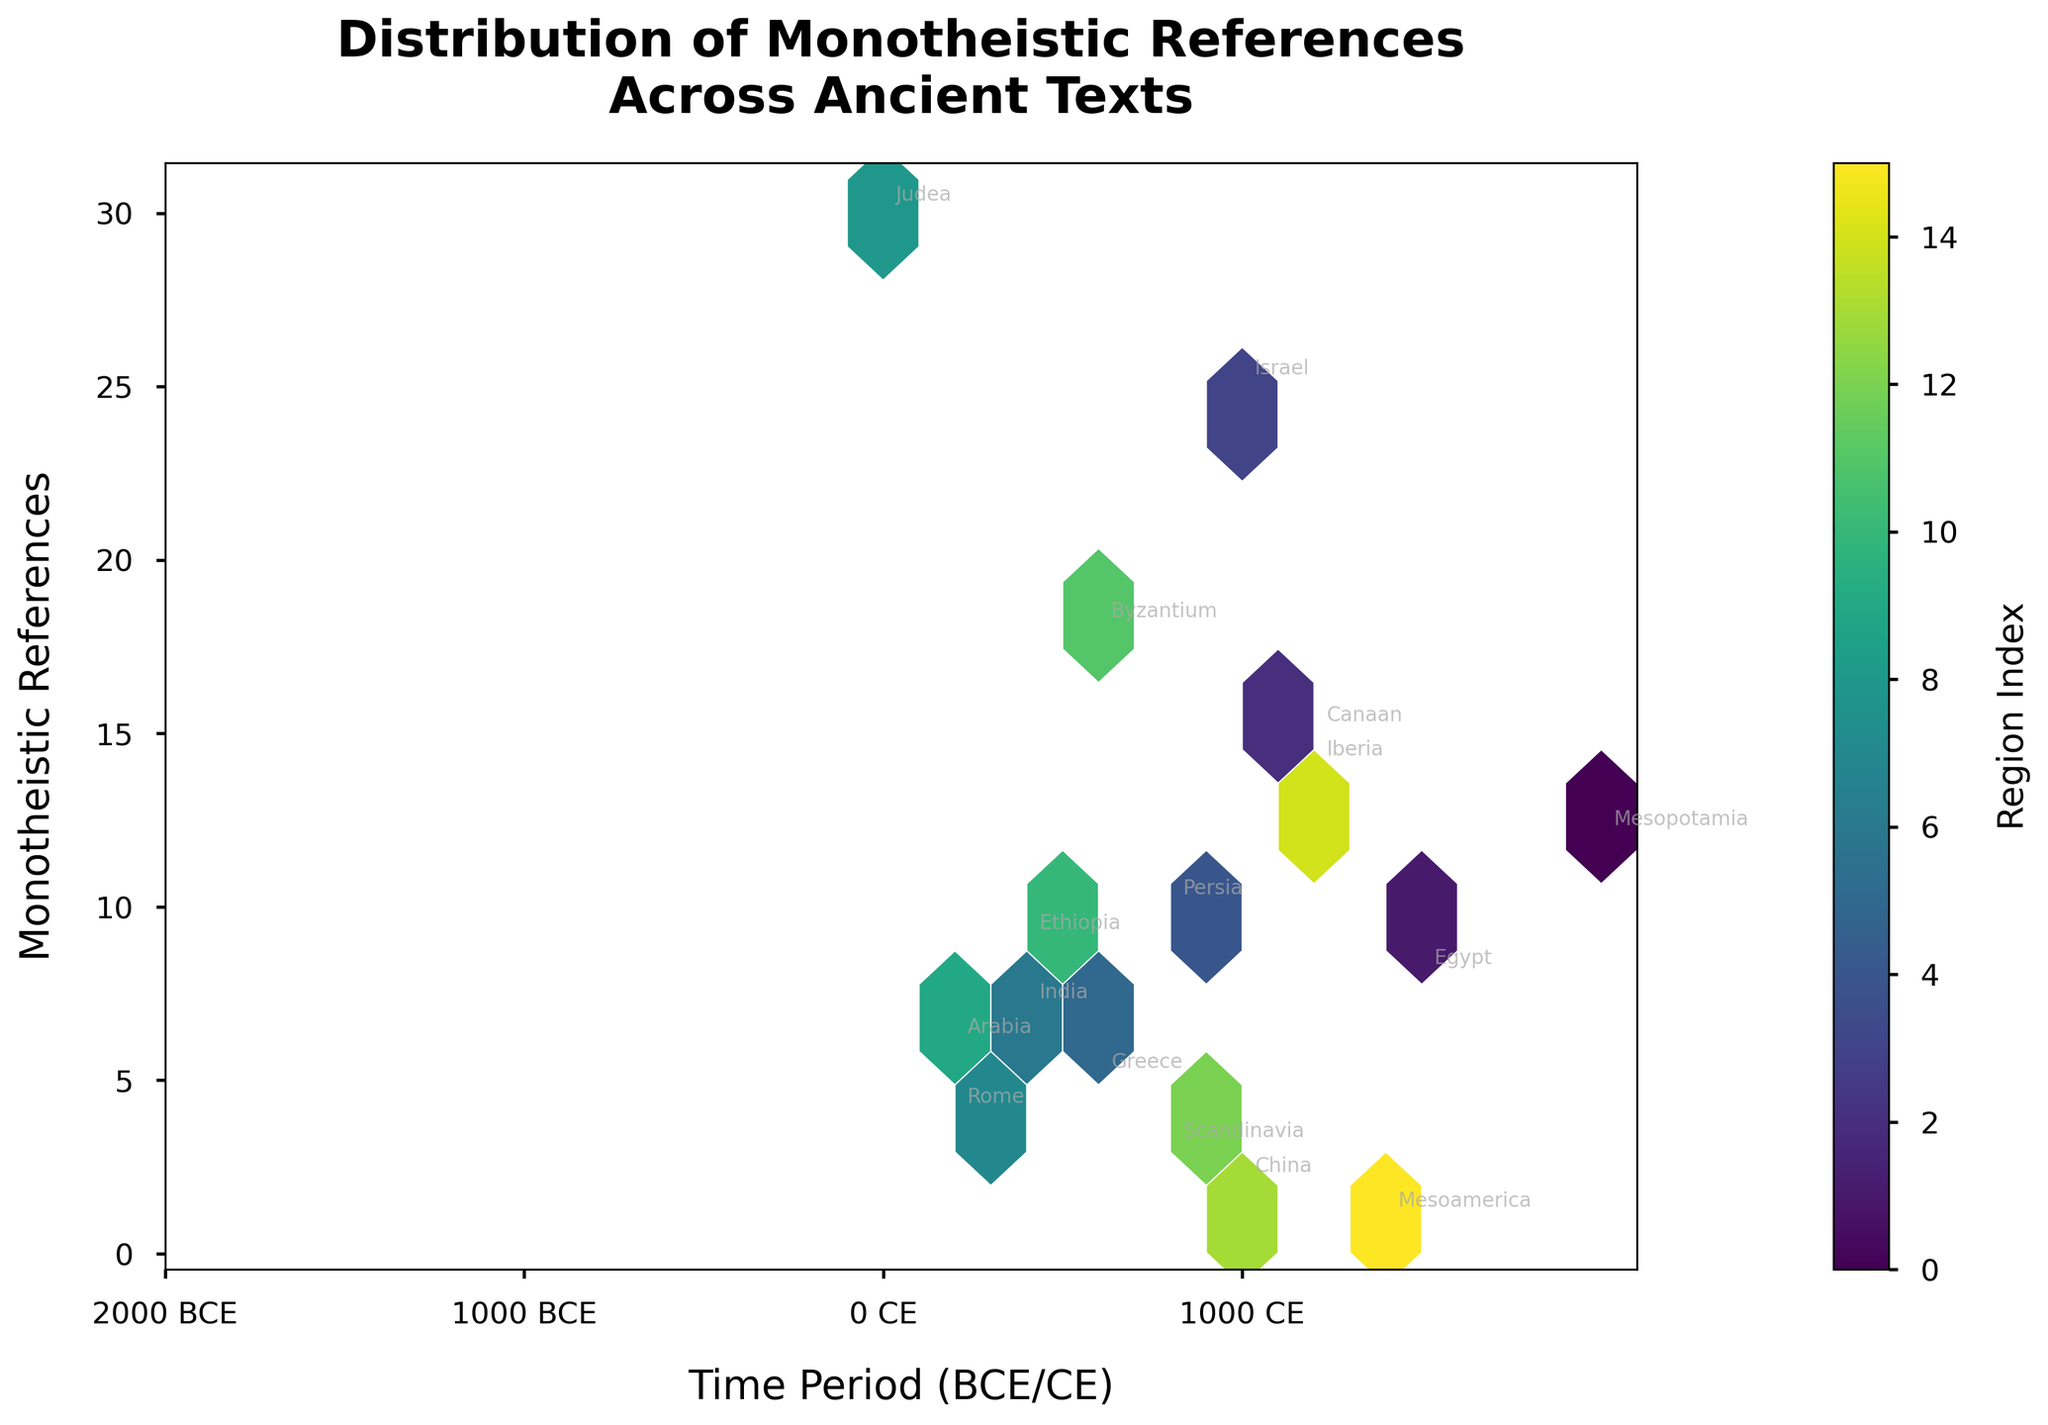What is the title of the hexbin plot? The title of the plot is displayed prominently at the top, in larger and bold text.
Answer: Distribution of Monotheistic References Across Ancient Texts What time periods are annotated on the x-axis? The x-axis ticks are labeled with significant time periods, marked with BCE (Before Common Era) or CE (Common Era) to indicate ancient and more recent times respectively.
Answer: 2000 BCE, 1000 BCE, 0 CE, 1000 CE How many regions have the highest density of monotheistic references? The regions with the highest density are indicated by the most heavily color-coded hexagons. Observing the plot, we can count the most densely occupied areas.
Answer: 1 Which region has the highest number of monotheistic references and in what time period? The hexbin plot annotations show the areas with the most monotheistic references, alongside text labels for time periods and regions. The highest point's annotation indicates the region.
Answer: Judea, 0 CE Which two regions have the lowest monotheistic references and what are their respective times? By finding the least dense or lowest hexagons, we identify annotations for regions and corresponding time periods with minimal references.
Answer: Mesoamerica (1400 CE) and China (1000 CE) How are time periods labeled around the 0 value on the hexbin plot? Centering around the transition from BCE to CE (0 value), the plot marks this boundary distinctly with the 0 CE tick label on the x-axis.
Answer: As 0 CE What is the range of monotheistic references shown on the y-axis? The y-axis, which indicates the number of monotheistic references, has a specific range of numbers delineated at its lower and upper bounds.
Answer: 1 to 30 Which period had a second peak in monotheistic references, and what is its approximate count? A secondary peak apart from the highest is identified through dense hexagons; annotations will indicate the period and rough count.
Answer: 1000 BCE, approximately 25 references Which geographical region is represented by the highest density of references around 600 CE? Observing hexagon density and annotation for 600 CE, the region label next to the peak will identify the geographical area.
Answer: Byzantium Are there any regions with monotheistic references spanning BCE and CE eras? Regions with references spanning both eras will be identifiable by annotations on both sides of 0 CE on the x-axis. Check if any region appears in both BCE and CE.
Answer: No 